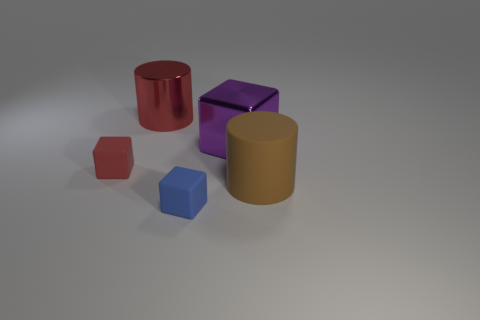Add 4 green shiny cylinders. How many objects exist? 9 Subtract all cylinders. How many objects are left? 3 Add 4 matte cubes. How many matte cubes are left? 6 Add 4 blue matte cylinders. How many blue matte cylinders exist? 4 Subtract 0 yellow cylinders. How many objects are left? 5 Subtract all tiny balls. Subtract all big red things. How many objects are left? 4 